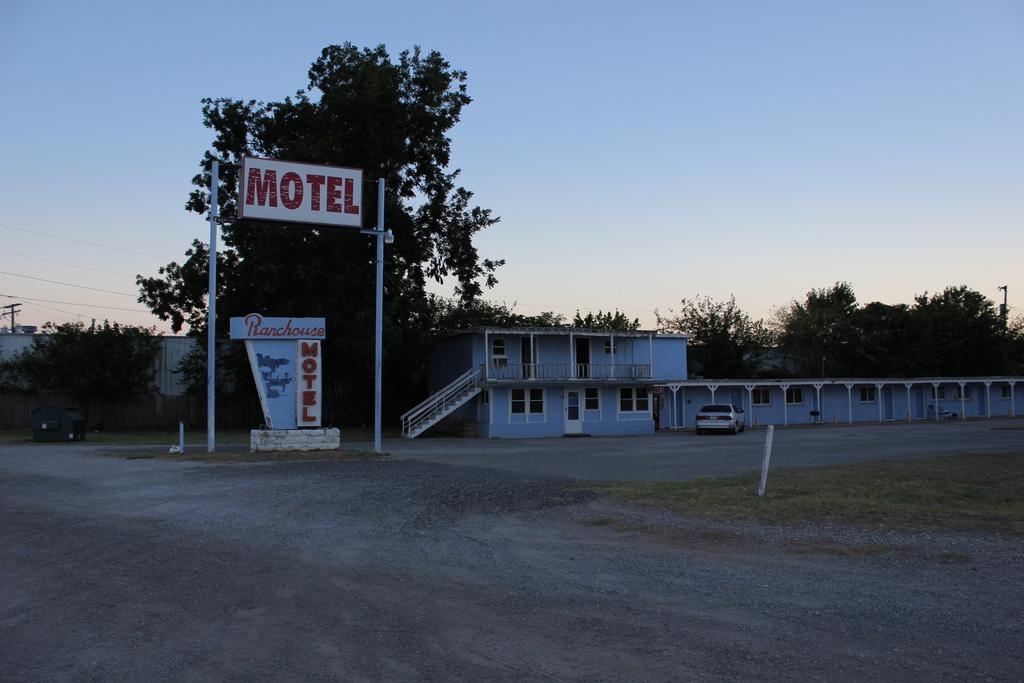Could you give a brief overview of what you see in this image? In this image there is a building. Before it there is a car on the land. Left side a board is attached to the poles. Behind there is a board on the wall. Background there are few trees. Left side there is a building. Top of the image there is sky. 